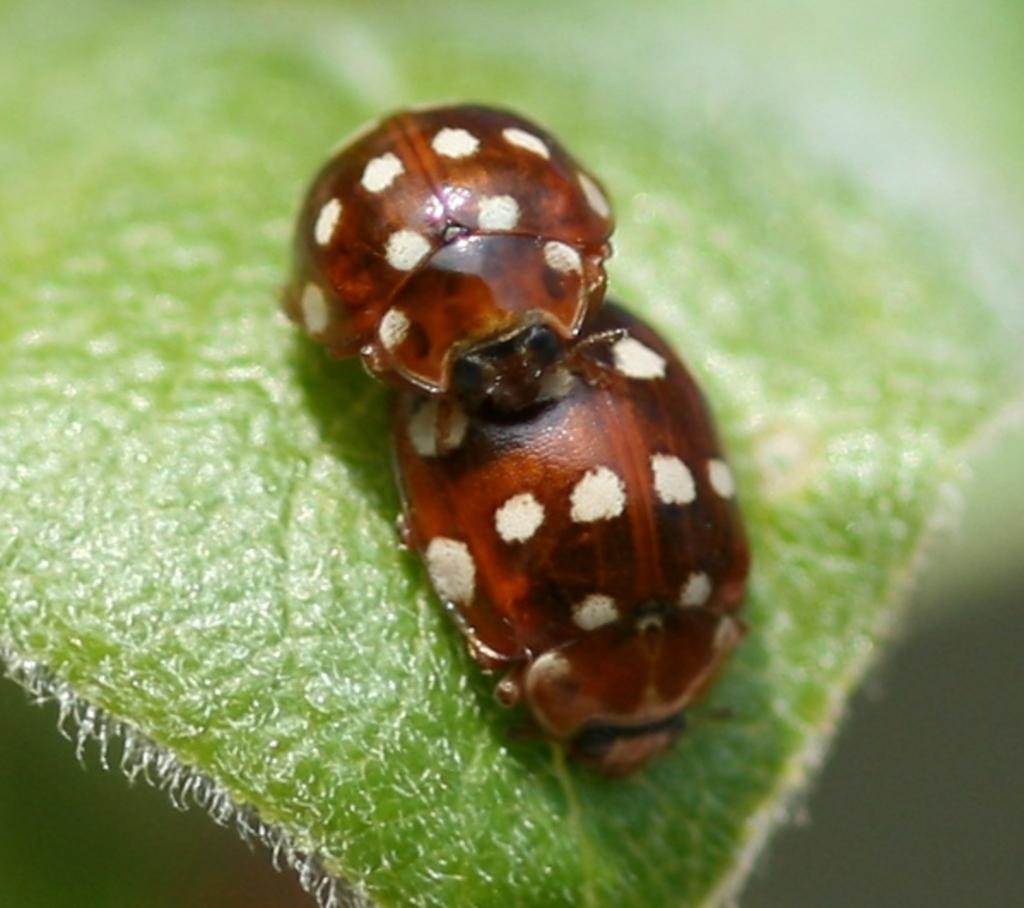In one or two sentences, can you explain what this image depicts? In the center of the image we can see bugs on the leaf. 